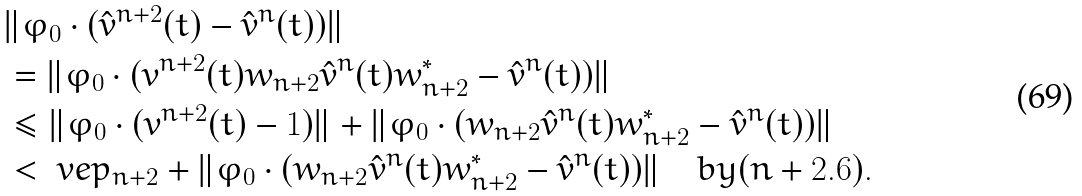Convert formula to latex. <formula><loc_0><loc_0><loc_500><loc_500>& \| \varphi _ { 0 } \cdot ( \hat { v } ^ { n + 2 } ( t ) - \hat { v } ^ { n } ( t ) ) \| \\ & = \| \varphi _ { 0 } \cdot ( { v } ^ { n + 2 } ( t ) w _ { n + 2 } \hat { v } ^ { n } ( t ) w _ { n + 2 } ^ { * } - \hat { v } ^ { n } ( t ) ) \| \\ & \leq \| \varphi _ { 0 } \cdot ( { v } ^ { n + 2 } ( t ) - 1 ) \| + \| \varphi _ { 0 } \cdot ( w _ { n + 2 } \hat { v } ^ { n } ( t ) w _ { n + 2 } ^ { * } - \hat { v } ^ { n } ( t ) ) \| \\ & < \ v e p _ { n + 2 } + \| \varphi _ { 0 } \cdot ( w _ { n + 2 } \hat { v } ^ { n } ( t ) w _ { n + 2 } ^ { * } - \hat { v } ^ { n } ( t ) ) \| \quad b y ( n + 2 . 6 ) .</formula> 